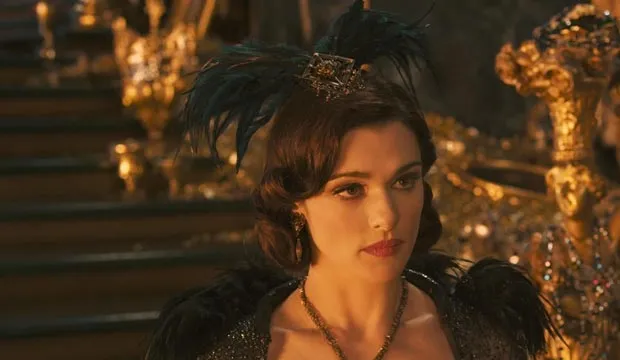Can you describe the main features of this image for me? In this captivating image, we see the acclaimed actress Rachel Weisz fully immersed in her character, Evanora, from the movie "Oz the Great and Powerful". She stands regally in front of a golden throne, her posture exuding an air of authority. Her attire is a striking combination of black and gold, with a black feathered headpiece adorned with a gold crown resting on her head, and a matching black and gold dress draped elegantly around her. Her gaze is directed off to the side, her face set in a serious expression, hinting at the gravity of the scene unfolding. 